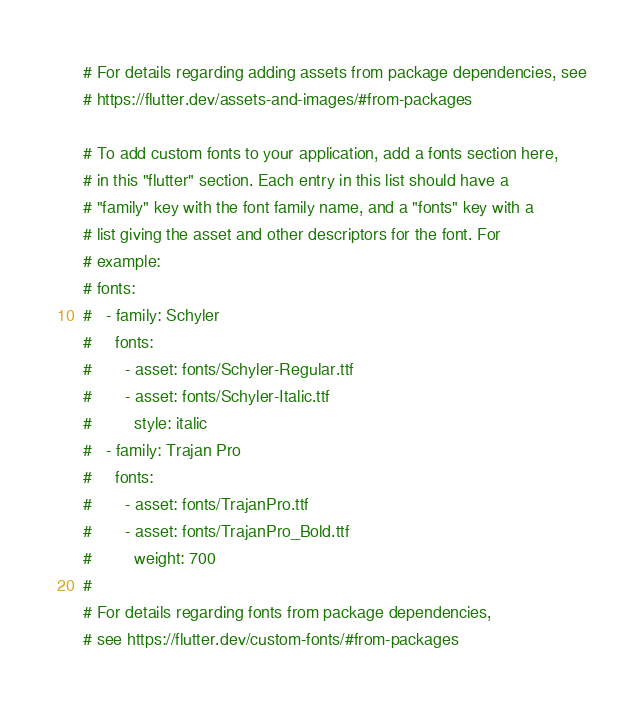Convert code to text. <code><loc_0><loc_0><loc_500><loc_500><_YAML_>
  # For details regarding adding assets from package dependencies, see
  # https://flutter.dev/assets-and-images/#from-packages

  # To add custom fonts to your application, add a fonts section here,
  # in this "flutter" section. Each entry in this list should have a
  # "family" key with the font family name, and a "fonts" key with a
  # list giving the asset and other descriptors for the font. For
  # example:
  # fonts:
  #   - family: Schyler
  #     fonts:
  #       - asset: fonts/Schyler-Regular.ttf
  #       - asset: fonts/Schyler-Italic.ttf
  #         style: italic
  #   - family: Trajan Pro
  #     fonts:
  #       - asset: fonts/TrajanPro.ttf
  #       - asset: fonts/TrajanPro_Bold.ttf
  #         weight: 700
  #
  # For details regarding fonts from package dependencies,
  # see https://flutter.dev/custom-fonts/#from-packages
</code> 